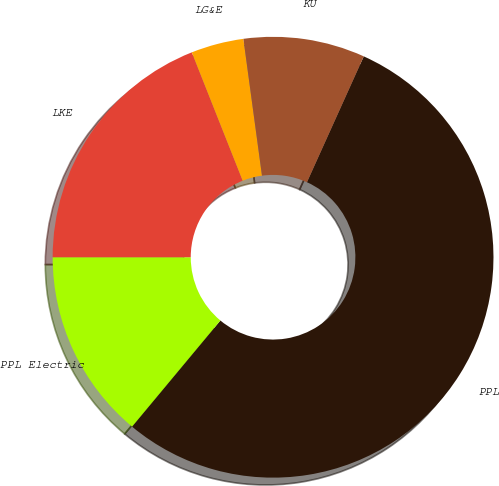Convert chart. <chart><loc_0><loc_0><loc_500><loc_500><pie_chart><fcel>PPL<fcel>PPL Electric<fcel>LKE<fcel>LG&E<fcel>KU<nl><fcel>54.3%<fcel>13.95%<fcel>18.99%<fcel>3.86%<fcel>8.9%<nl></chart> 